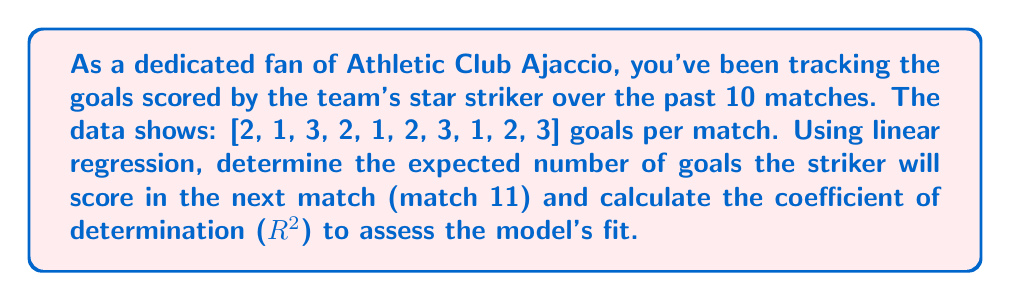Can you answer this question? Let's approach this step-by-step using linear regression:

1) First, we need to set up our data:
   $x$ (match number): [1, 2, 3, 4, 5, 6, 7, 8, 9, 10]
   $y$ (goals scored): [2, 1, 3, 2, 1, 2, 3, 1, 2, 3]

2) Calculate the means:
   $\bar{x} = \frac{1+2+3+4+5+6+7+8+9+10}{10} = 5.5$
   $\bar{y} = \frac{2+1+3+2+1+2+3+1+2+3}{10} = 2$

3) Calculate the slope ($m$) of the regression line:
   $m = \frac{\sum(x_i - \bar{x})(y_i - \bar{y})}{\sum(x_i - \bar{x})^2}$

   $\sum(x_i - \bar{x})(y_i - \bar{y}) = 3.5$
   $\sum(x_i - \bar{x})^2 = 82.5$

   $m = \frac{3.5}{82.5} = 0.0424$

4) Calculate the y-intercept ($b$):
   $b = \bar{y} - m\bar{x} = 2 - 0.0424(5.5) = 1.7668$

5) The regression line equation is:
   $y = 0.0424x + 1.7668$

6) To predict the goals for match 11:
   $y = 0.0424(11) + 1.7668 = 2.2332$

7) To calculate $R^2$, we need:
   $SS_{tot} = \sum(y_i - \bar{y})^2 = 6$
   $SS_{res} = \sum(y_i - (mx_i + b))^2 = 5.8529$

   $R^2 = 1 - \frac{SS_{res}}{SS_{tot}} = 1 - \frac{5.8529}{6} = 0.0245$
Answer: 2.23 goals; $R^2 = 0.0245$ 